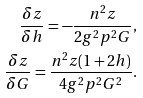Convert formula to latex. <formula><loc_0><loc_0><loc_500><loc_500>\frac { \delta z } { \delta h } = - \frac { n ^ { 2 } z } { 2 g ^ { 2 } p ^ { 2 } G } , \\ \frac { \delta z } { \delta G } = \frac { n ^ { 2 } z ( 1 + 2 h ) } { 4 g ^ { 2 } p ^ { 2 } G ^ { 2 } } .</formula> 